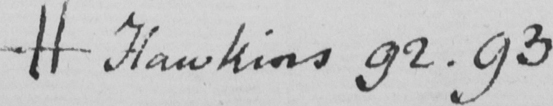What text is written in this handwritten line? # Hawkins 92.93 